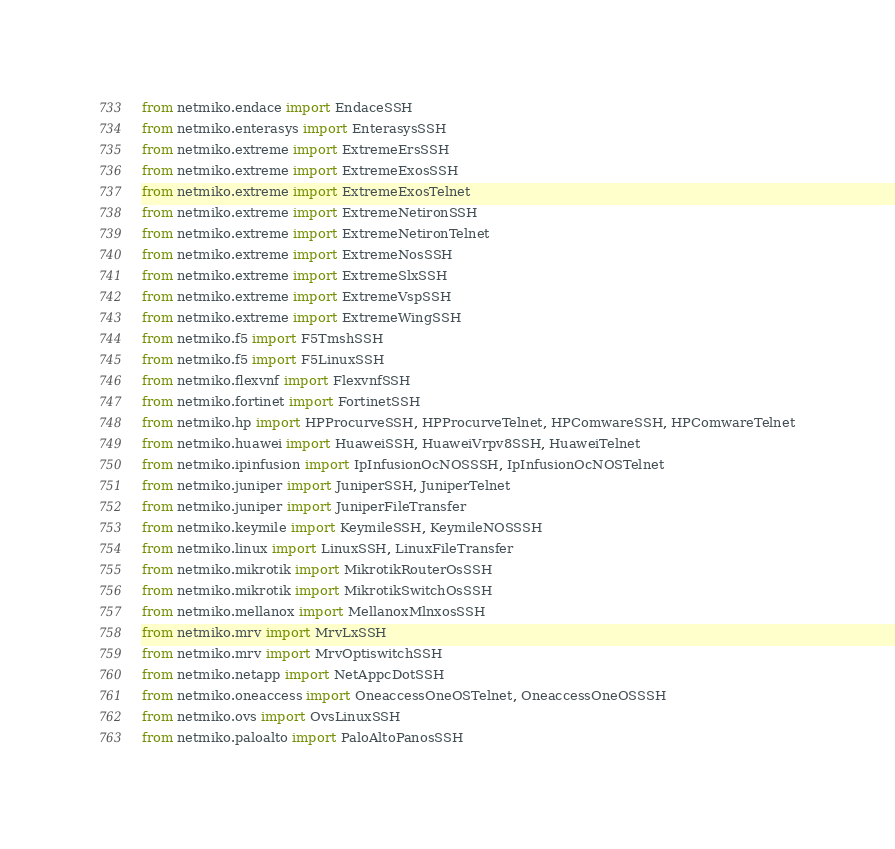<code> <loc_0><loc_0><loc_500><loc_500><_Python_>from netmiko.endace import EndaceSSH
from netmiko.enterasys import EnterasysSSH
from netmiko.extreme import ExtremeErsSSH
from netmiko.extreme import ExtremeExosSSH
from netmiko.extreme import ExtremeExosTelnet
from netmiko.extreme import ExtremeNetironSSH
from netmiko.extreme import ExtremeNetironTelnet
from netmiko.extreme import ExtremeNosSSH
from netmiko.extreme import ExtremeSlxSSH
from netmiko.extreme import ExtremeVspSSH
from netmiko.extreme import ExtremeWingSSH
from netmiko.f5 import F5TmshSSH
from netmiko.f5 import F5LinuxSSH
from netmiko.flexvnf import FlexvnfSSH
from netmiko.fortinet import FortinetSSH
from netmiko.hp import HPProcurveSSH, HPProcurveTelnet, HPComwareSSH, HPComwareTelnet
from netmiko.huawei import HuaweiSSH, HuaweiVrpv8SSH, HuaweiTelnet
from netmiko.ipinfusion import IpInfusionOcNOSSSH, IpInfusionOcNOSTelnet
from netmiko.juniper import JuniperSSH, JuniperTelnet
from netmiko.juniper import JuniperFileTransfer
from netmiko.keymile import KeymileSSH, KeymileNOSSSH
from netmiko.linux import LinuxSSH, LinuxFileTransfer
from netmiko.mikrotik import MikrotikRouterOsSSH
from netmiko.mikrotik import MikrotikSwitchOsSSH
from netmiko.mellanox import MellanoxMlnxosSSH
from netmiko.mrv import MrvLxSSH
from netmiko.mrv import MrvOptiswitchSSH
from netmiko.netapp import NetAppcDotSSH
from netmiko.oneaccess import OneaccessOneOSTelnet, OneaccessOneOSSSH
from netmiko.ovs import OvsLinuxSSH
from netmiko.paloalto import PaloAltoPanosSSH</code> 